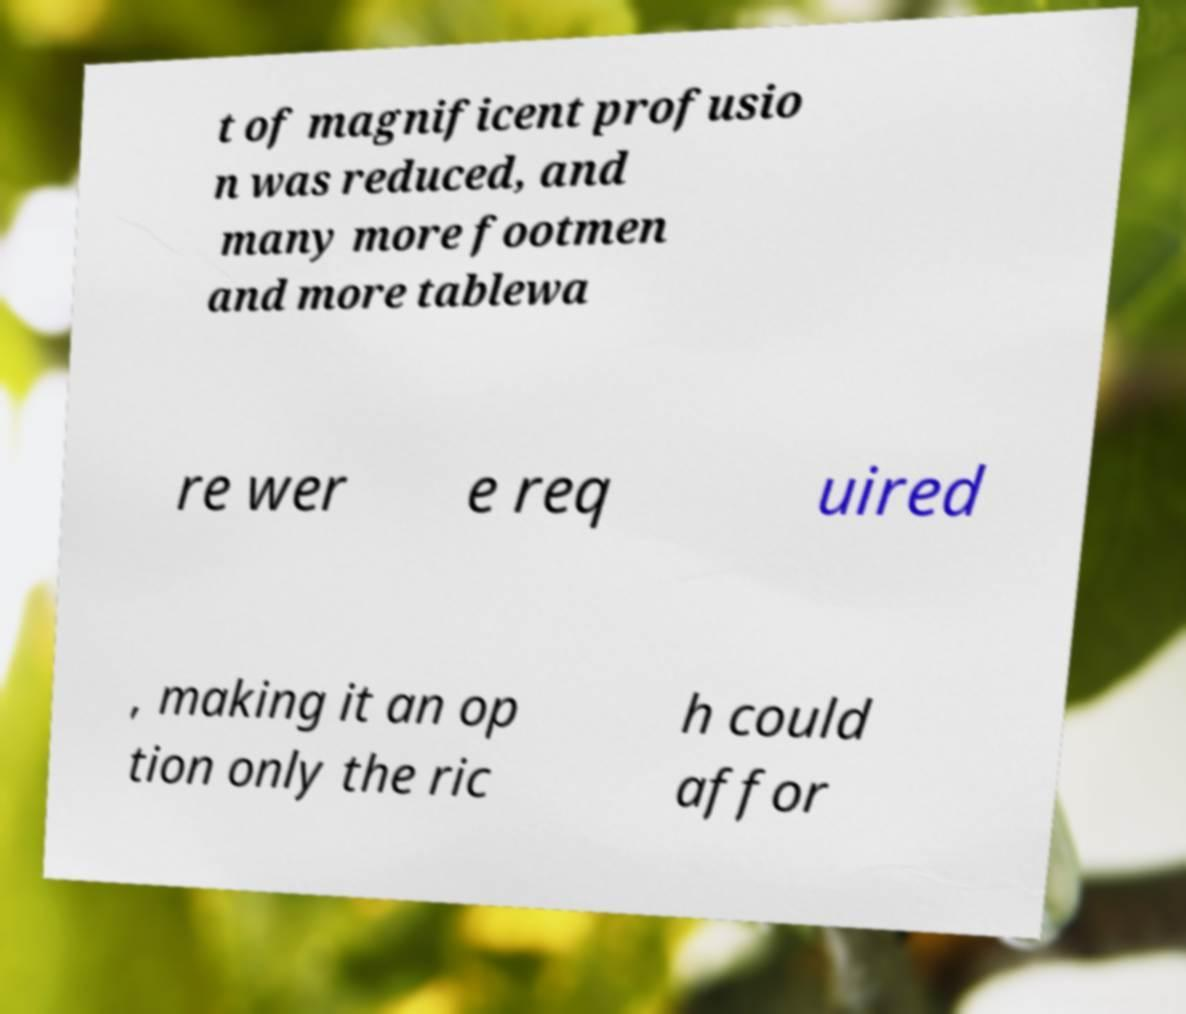What messages or text are displayed in this image? I need them in a readable, typed format. t of magnificent profusio n was reduced, and many more footmen and more tablewa re wer e req uired , making it an op tion only the ric h could affor 